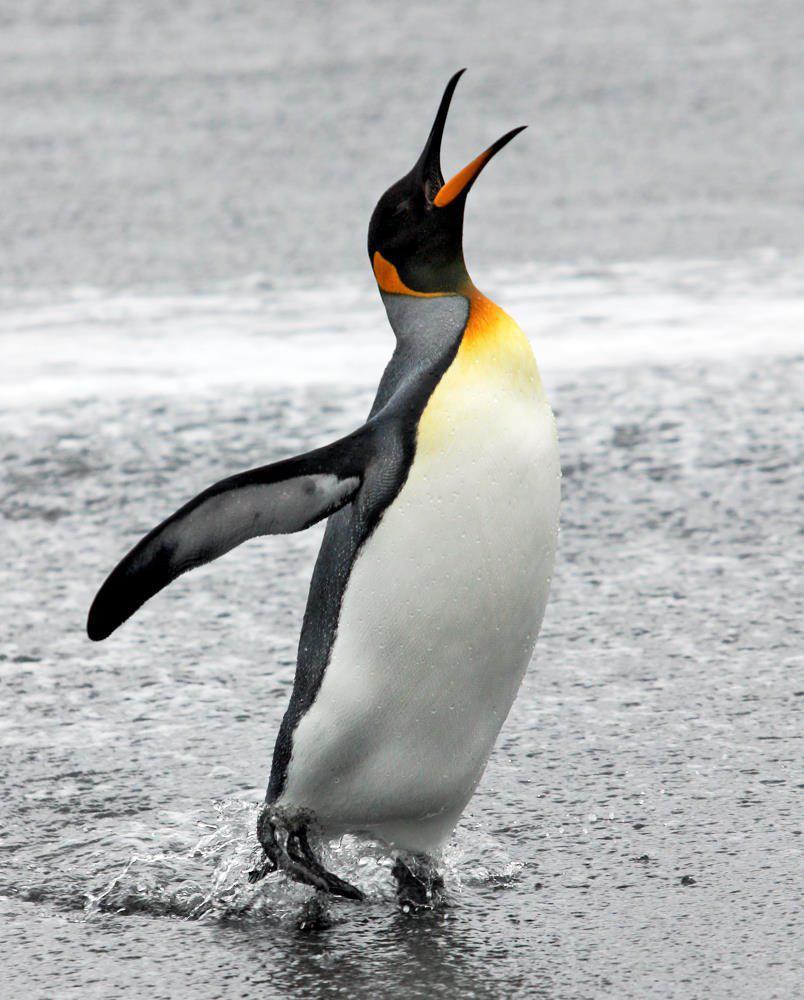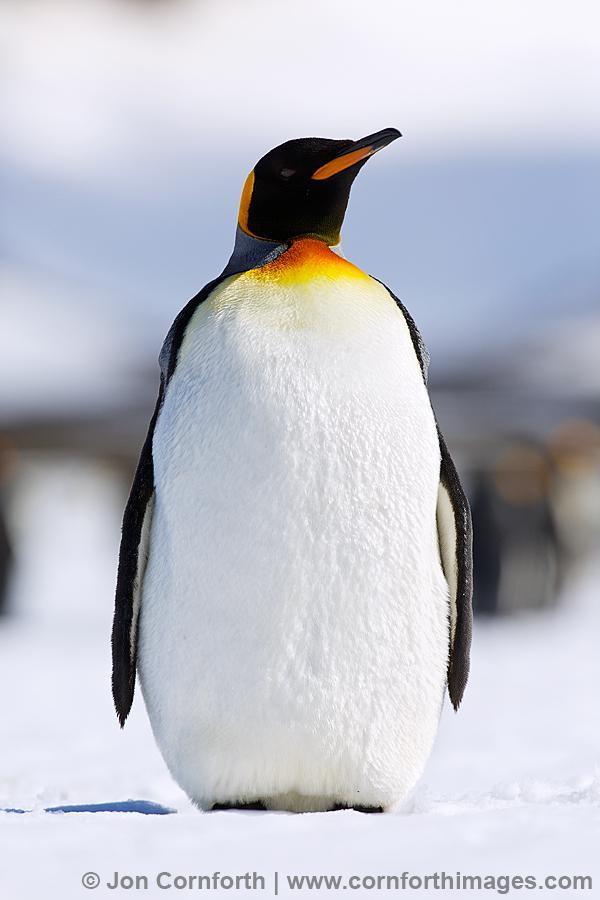The first image is the image on the left, the second image is the image on the right. For the images shown, is this caption "One image has one penguin flexing its wings away from its body while its head is facing upwards." true? Answer yes or no. Yes. The first image is the image on the left, the second image is the image on the right. Considering the images on both sides, is "In one of the image a penguin is standing in snow." valid? Answer yes or no. Yes. 